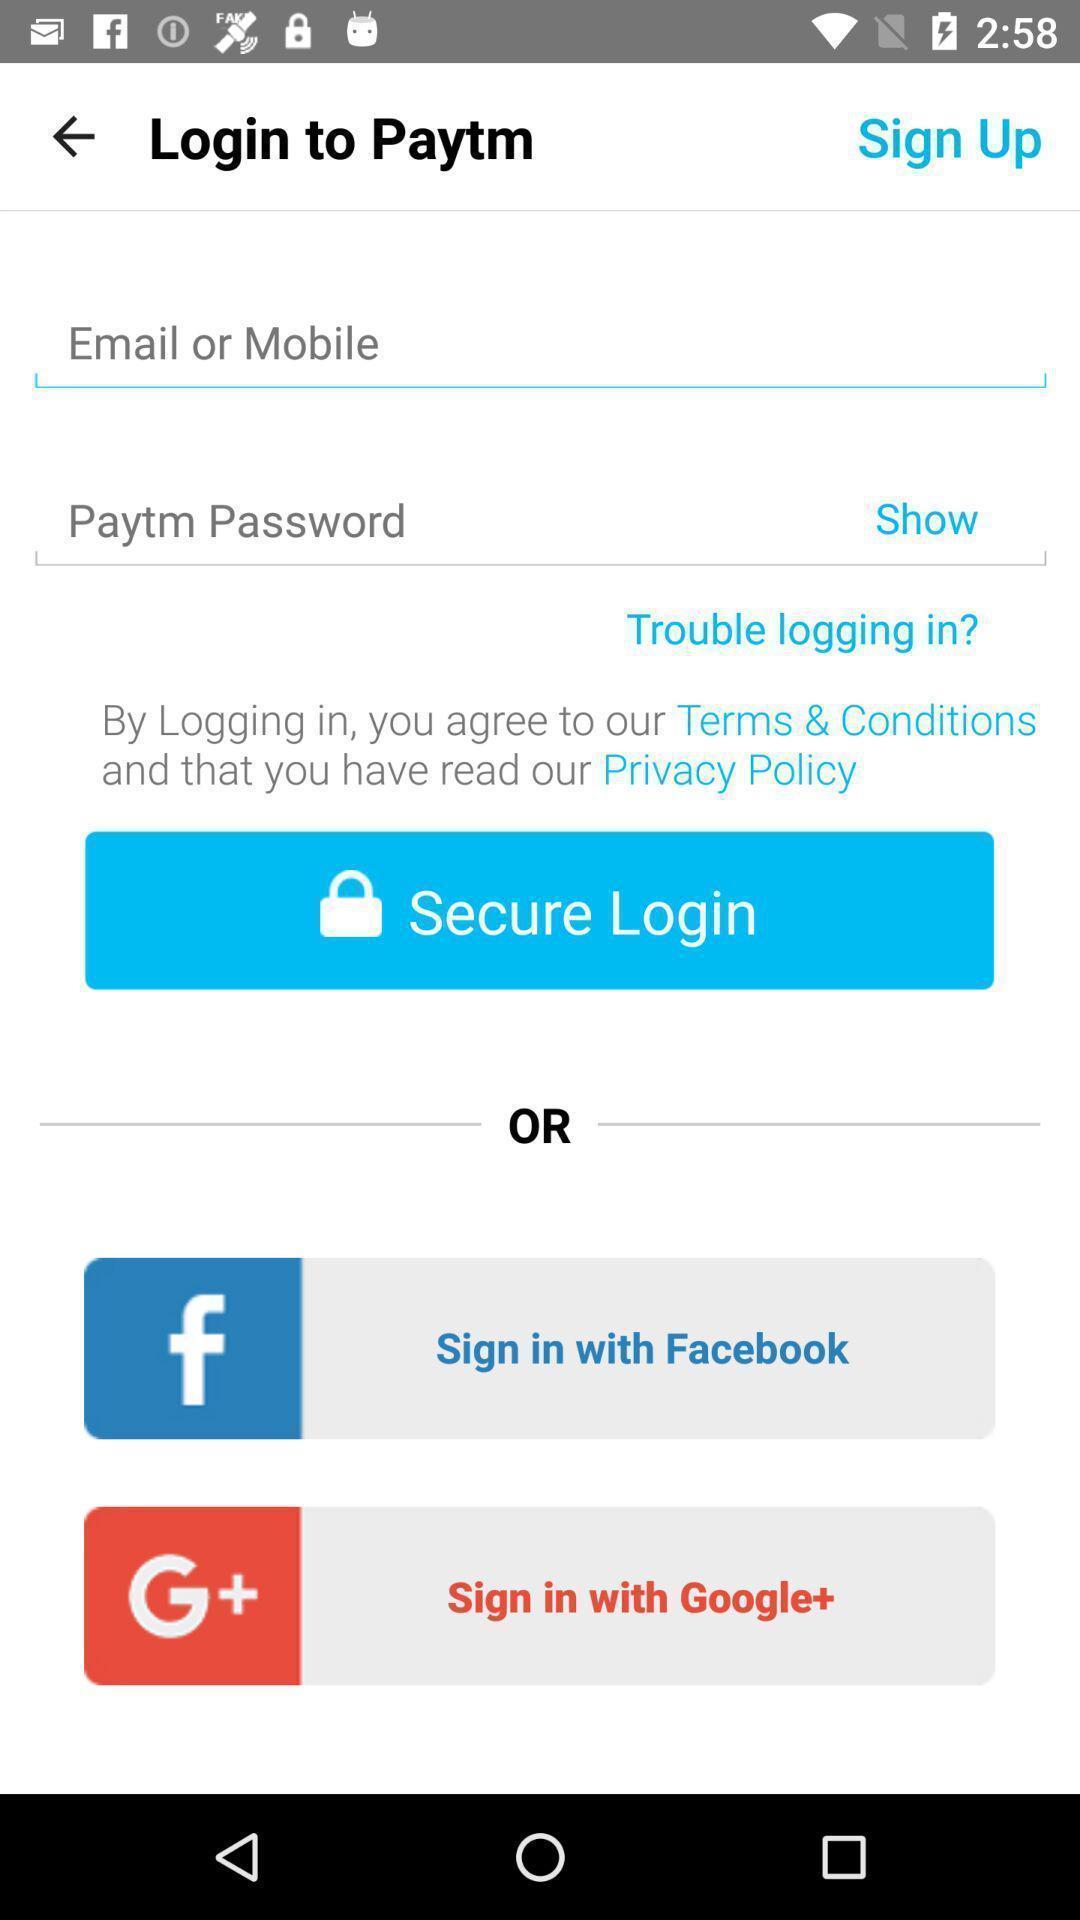Give me a summary of this screen capture. Page showing login credentials options. 